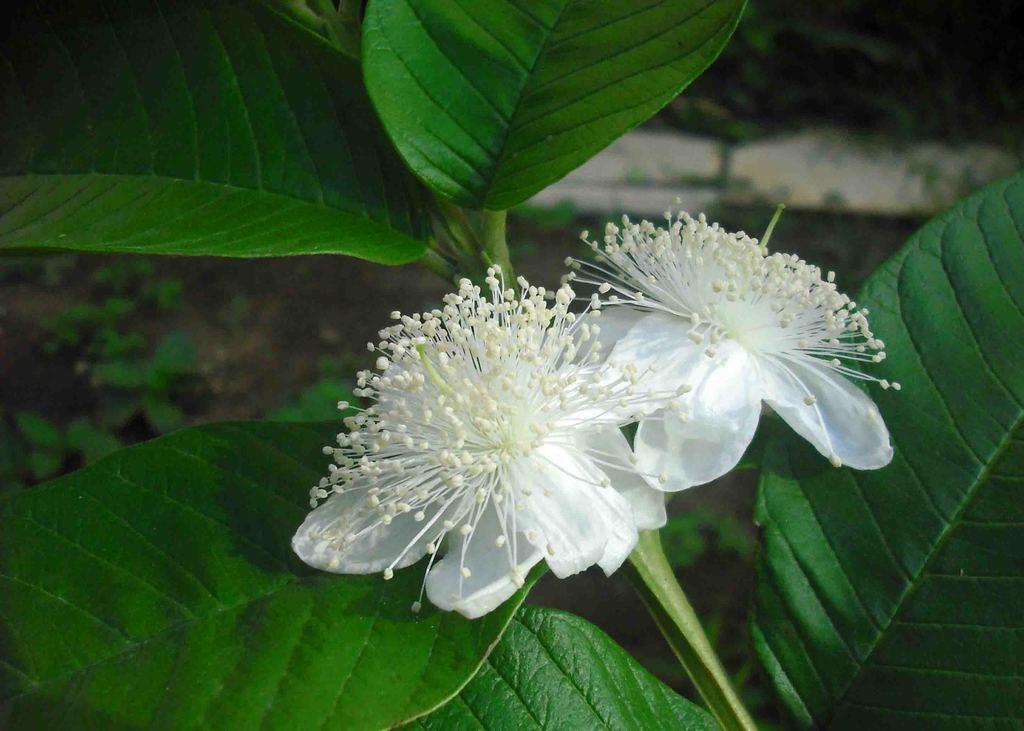Describe this image in one or two sentences. In the image,there are two flowers to the guava tree. 